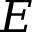<formula> <loc_0><loc_0><loc_500><loc_500>E</formula> 